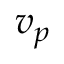Convert formula to latex. <formula><loc_0><loc_0><loc_500><loc_500>v _ { p }</formula> 